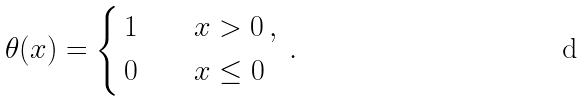<formula> <loc_0><loc_0><loc_500><loc_500>\theta ( x ) = \begin{dcases} \, 1 \quad & x > 0 \, , \\ \, 0 \quad & x \leq 0 \, \end{dcases} \, .</formula> 